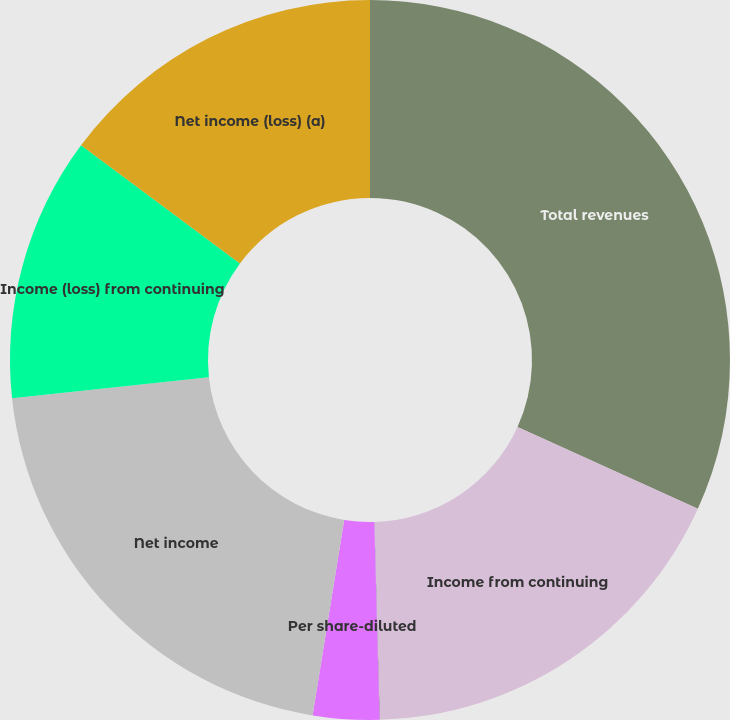<chart> <loc_0><loc_0><loc_500><loc_500><pie_chart><fcel>Total revenues<fcel>Income from continuing<fcel>Per share-basic<fcel>Per share-diluted<fcel>Net income<fcel>Income (loss) from continuing<fcel>Net income (loss) (a)<nl><fcel>31.78%<fcel>17.79%<fcel>0.01%<fcel>2.97%<fcel>20.76%<fcel>11.86%<fcel>14.83%<nl></chart> 